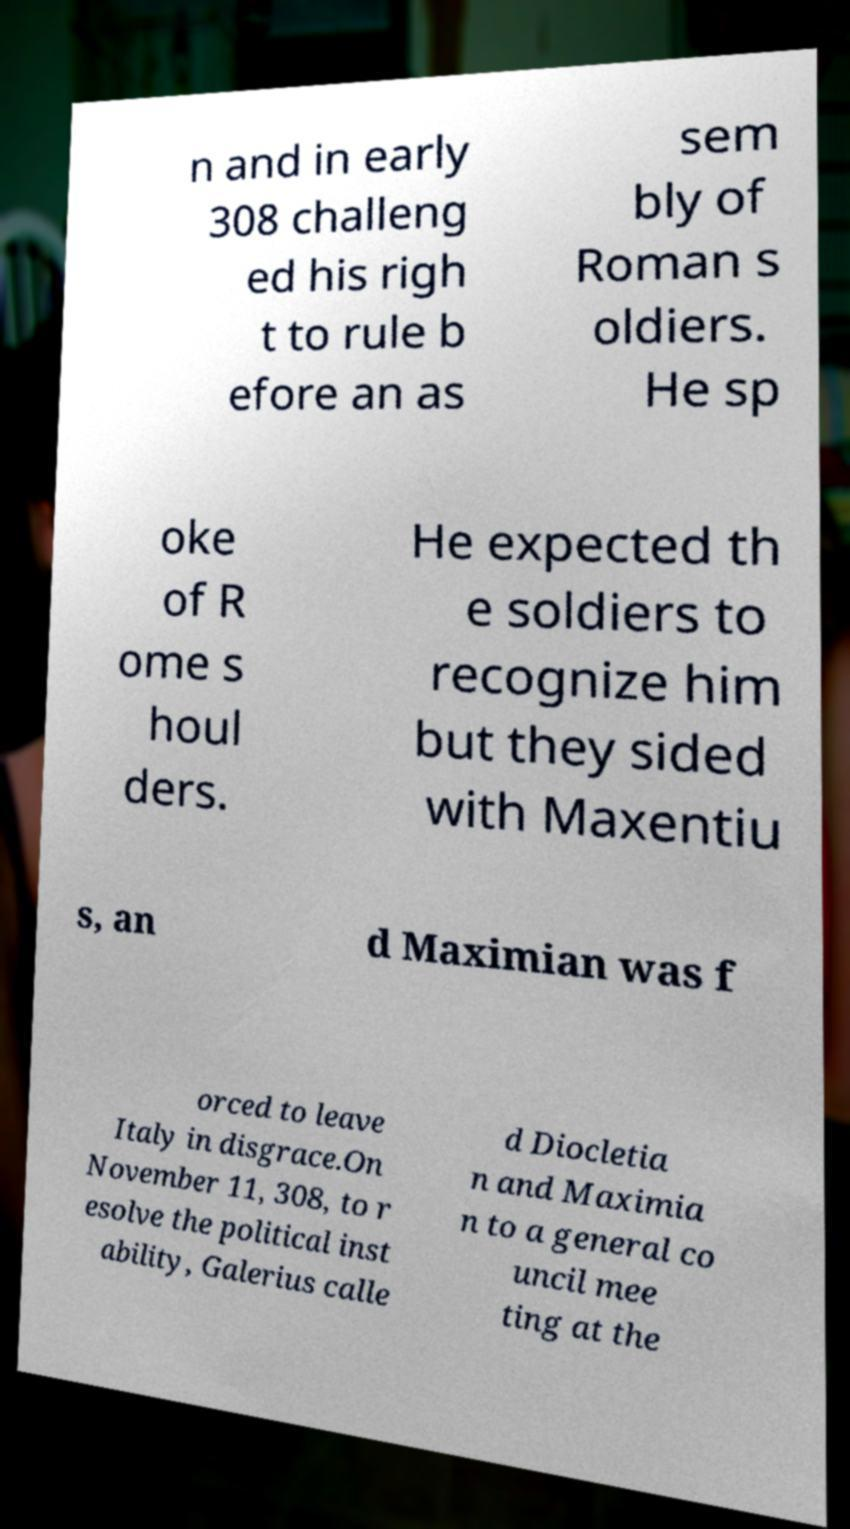Can you read and provide the text displayed in the image?This photo seems to have some interesting text. Can you extract and type it out for me? n and in early 308 challeng ed his righ t to rule b efore an as sem bly of Roman s oldiers. He sp oke of R ome s houl ders. He expected th e soldiers to recognize him but they sided with Maxentiu s, an d Maximian was f orced to leave Italy in disgrace.On November 11, 308, to r esolve the political inst ability, Galerius calle d Diocletia n and Maximia n to a general co uncil mee ting at the 